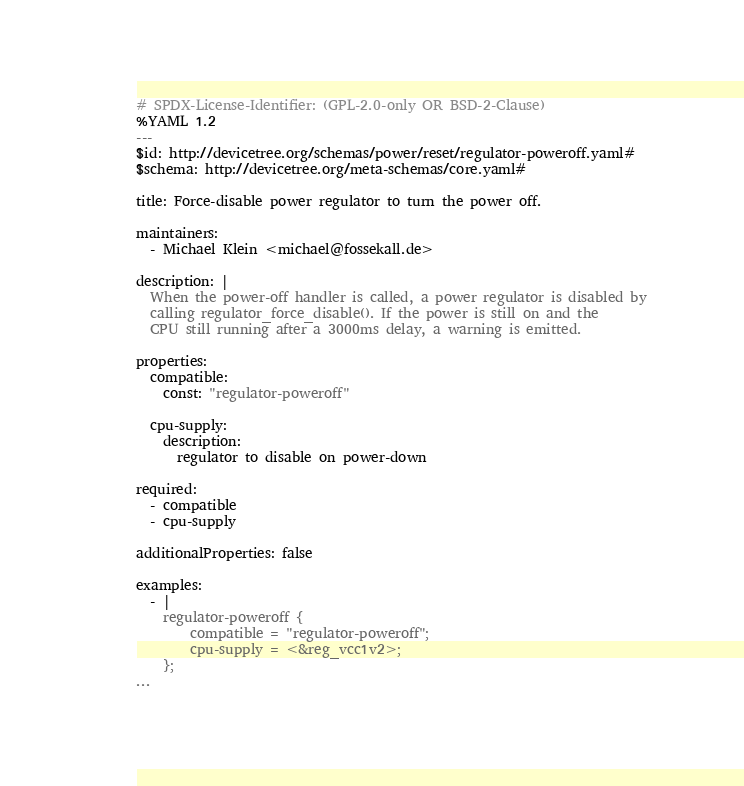<code> <loc_0><loc_0><loc_500><loc_500><_YAML_># SPDX-License-Identifier: (GPL-2.0-only OR BSD-2-Clause)
%YAML 1.2
---
$id: http://devicetree.org/schemas/power/reset/regulator-poweroff.yaml#
$schema: http://devicetree.org/meta-schemas/core.yaml#

title: Force-disable power regulator to turn the power off.

maintainers:
  - Michael Klein <michael@fossekall.de>

description: |
  When the power-off handler is called, a power regulator is disabled by
  calling regulator_force_disable(). If the power is still on and the
  CPU still running after a 3000ms delay, a warning is emitted.

properties:
  compatible:
    const: "regulator-poweroff"

  cpu-supply:
    description:
      regulator to disable on power-down

required:
  - compatible
  - cpu-supply

additionalProperties: false

examples:
  - |
    regulator-poweroff {
        compatible = "regulator-poweroff";
        cpu-supply = <&reg_vcc1v2>;
    };
...
</code> 